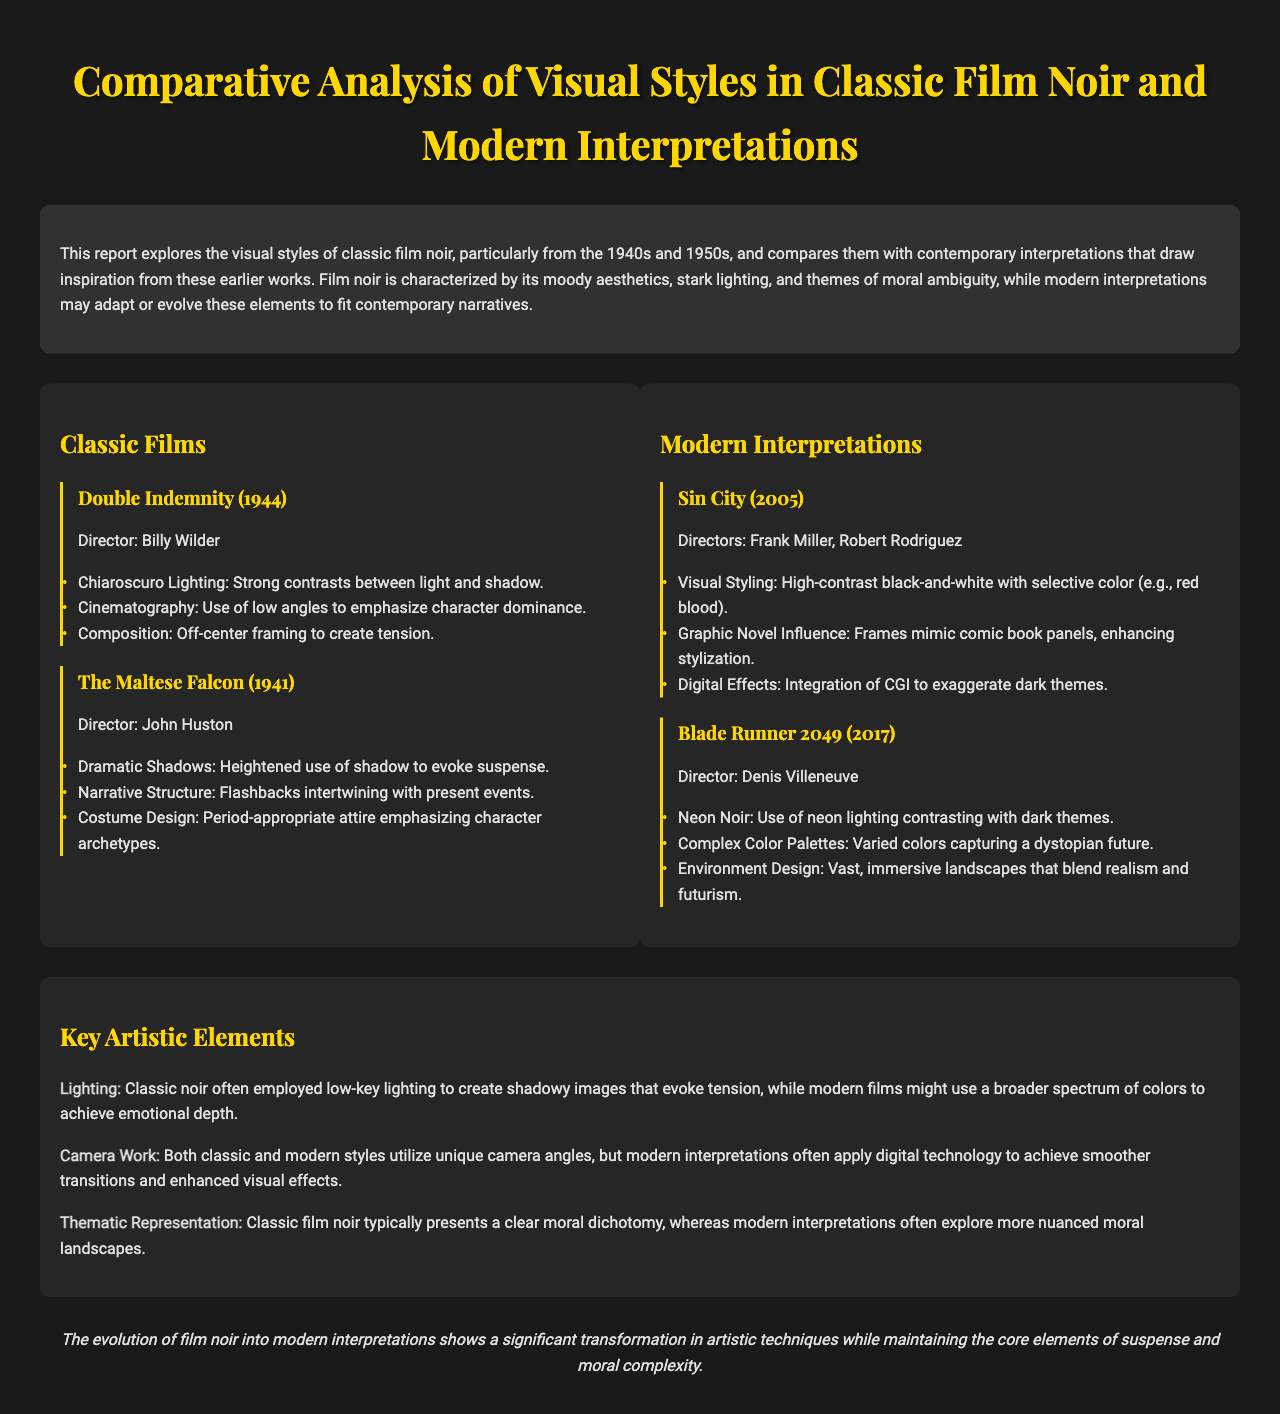What is the title of the report? The title of the report is the header seen at the top of the document.
Answer: Comparative Analysis of Visual Styles in Classic Film Noir and Modern Interpretations Who directed "Double Indemnity"? The director of "Double Indemnity" is listed alongside the film title in the classic films section.
Answer: Billy Wilder What year was "Blade Runner 2049" released? The release year of "Blade Runner 2049" is mentioned next to the film title in the modern interpretations section.
Answer: 2017 Name one artistic element that contrasts classic noir with modern interpretations. The document outlines key artistic elements comparing classic and modern styles.
Answer: Lighting What kind of lighting is described as used in classic film noir? The report provides specific details about the lighting techniques used in classic film noir.
Answer: Low-key lighting How many classic films are compared in the document? The number of classic films is the count of titles listed in the classic films section.
Answer: Two What unique stylistic aspect characterizes "Sin City"? The document mentions specific visual styles that characterize "Sin City."
Answer: High-contrast black-and-white with selective color What is a common theme in both classic and modern noir films? The conclusion summarizes the enduring themes present in both styles of film.
Answer: Moral complexity In what way does modern film noir adapt camera work compared to classic films? The document discusses trends in camera work across the two styles, as it mentions technological influences.
Answer: Digital technology 